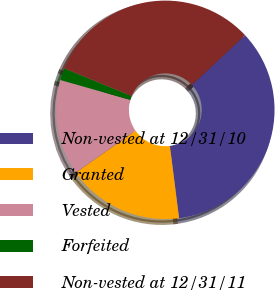Convert chart to OTSL. <chart><loc_0><loc_0><loc_500><loc_500><pie_chart><fcel>Non-vested at 12/31/10<fcel>Granted<fcel>Vested<fcel>Forfeited<fcel>Non-vested at 12/31/11<nl><fcel>34.97%<fcel>17.27%<fcel>14.14%<fcel>1.79%<fcel>31.83%<nl></chart> 